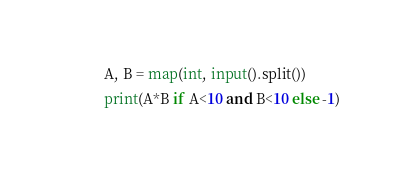<code> <loc_0><loc_0><loc_500><loc_500><_Python_>A, B = map(int, input().split())
print(A*B if A<10 and B<10 else -1)
</code> 